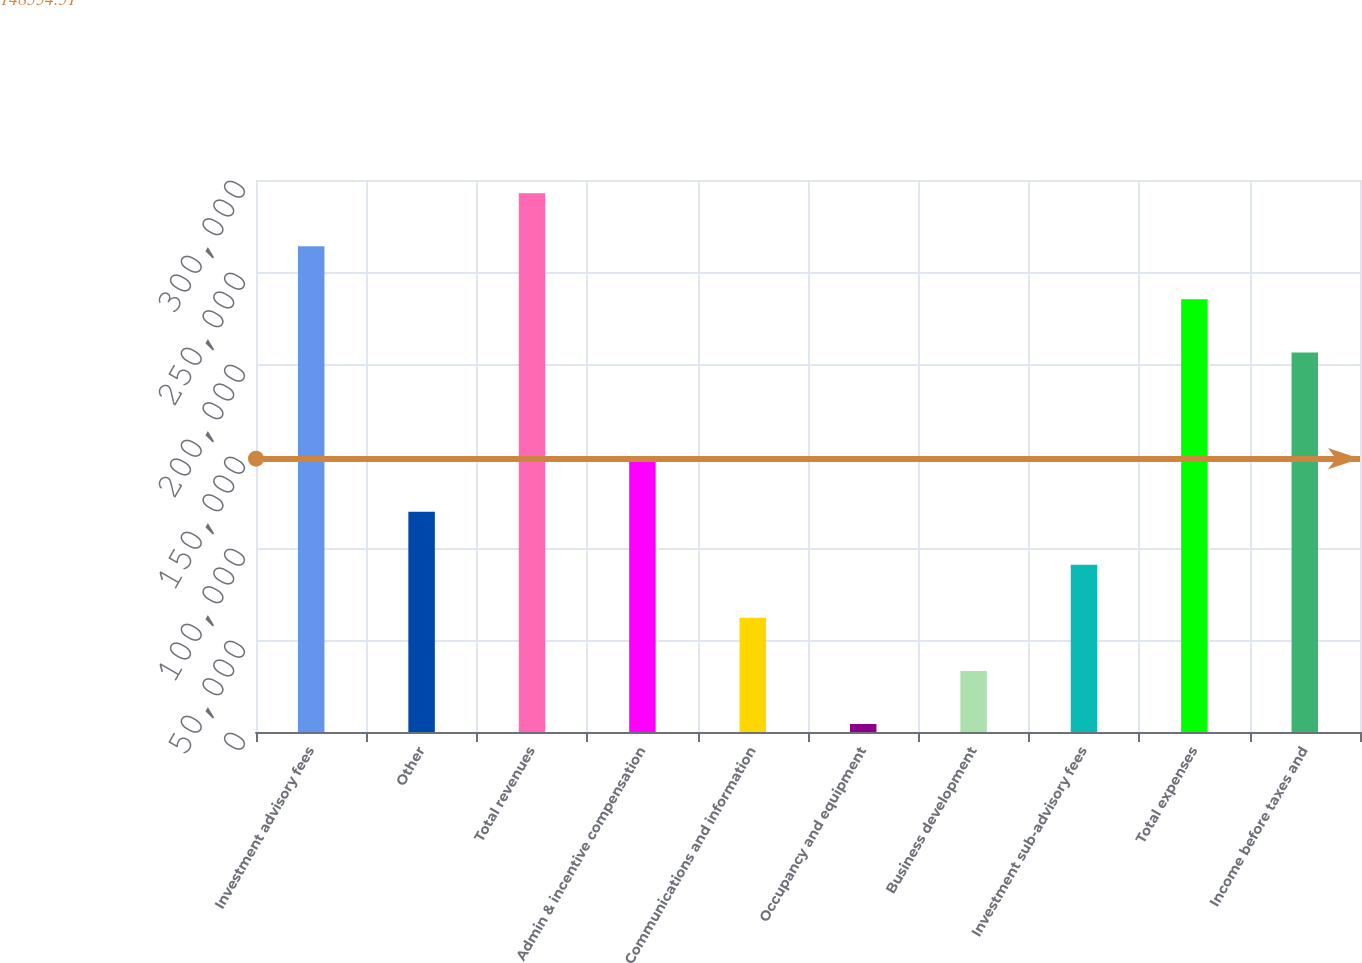<chart> <loc_0><loc_0><loc_500><loc_500><bar_chart><fcel>Investment advisory fees<fcel>Other<fcel>Total revenues<fcel>Admin & incentive compensation<fcel>Communications and information<fcel>Occupancy and equipment<fcel>Business development<fcel>Investment sub-advisory fees<fcel>Total expenses<fcel>Income before taxes and<nl><fcel>263972<fcel>119745<fcel>292817<fcel>148590<fcel>62054.6<fcel>4364<fcel>33209.3<fcel>90899.9<fcel>235126<fcel>206281<nl></chart> 